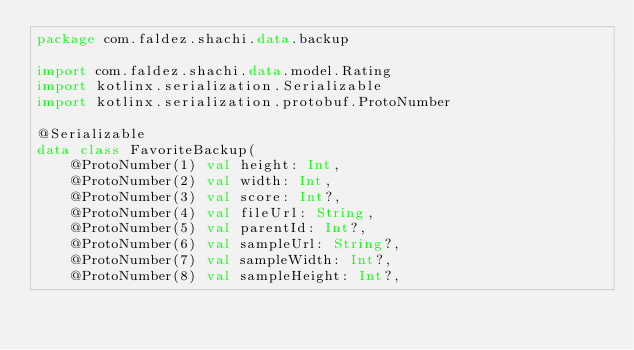<code> <loc_0><loc_0><loc_500><loc_500><_Kotlin_>package com.faldez.shachi.data.backup

import com.faldez.shachi.data.model.Rating
import kotlinx.serialization.Serializable
import kotlinx.serialization.protobuf.ProtoNumber

@Serializable
data class FavoriteBackup(
    @ProtoNumber(1) val height: Int,
    @ProtoNumber(2) val width: Int,
    @ProtoNumber(3) val score: Int?,
    @ProtoNumber(4) val fileUrl: String,
    @ProtoNumber(5) val parentId: Int?,
    @ProtoNumber(6) val sampleUrl: String?,
    @ProtoNumber(7) val sampleWidth: Int?,
    @ProtoNumber(8) val sampleHeight: Int?,</code> 